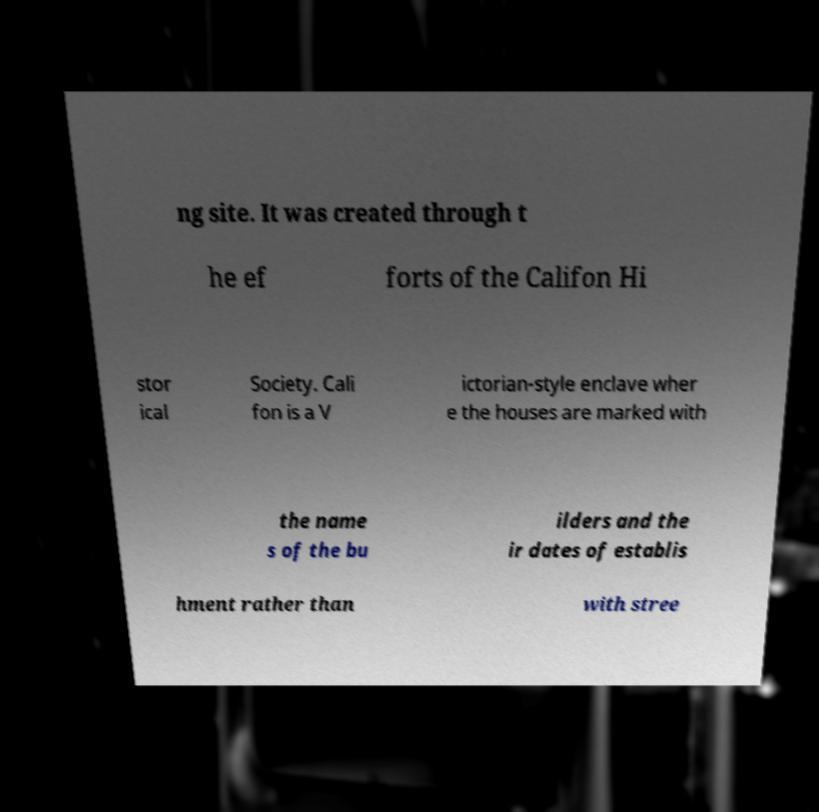Can you read and provide the text displayed in the image?This photo seems to have some interesting text. Can you extract and type it out for me? ng site. It was created through t he ef forts of the Califon Hi stor ical Society. Cali fon is a V ictorian-style enclave wher e the houses are marked with the name s of the bu ilders and the ir dates of establis hment rather than with stree 